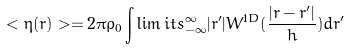<formula> <loc_0><loc_0><loc_500><loc_500>< \eta ( r ) > = 2 \pi \rho _ { 0 } \int \lim i t s _ { - \infty } ^ { \infty } | r ^ { \prime } | W ^ { 1 D } ( \frac { | r - r ^ { \prime } | } { h } ) d r ^ { \prime }</formula> 